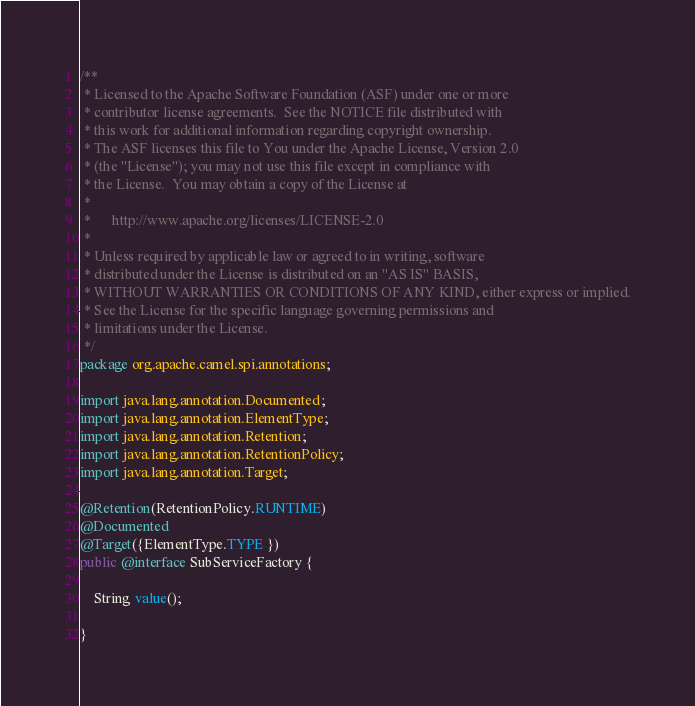Convert code to text. <code><loc_0><loc_0><loc_500><loc_500><_Java_>/**
 * Licensed to the Apache Software Foundation (ASF) under one or more
 * contributor license agreements.  See the NOTICE file distributed with
 * this work for additional information regarding copyright ownership.
 * The ASF licenses this file to You under the Apache License, Version 2.0
 * (the "License"); you may not use this file except in compliance with
 * the License.  You may obtain a copy of the License at
 *
 *      http://www.apache.org/licenses/LICENSE-2.0
 *
 * Unless required by applicable law or agreed to in writing, software
 * distributed under the License is distributed on an "AS IS" BASIS,
 * WITHOUT WARRANTIES OR CONDITIONS OF ANY KIND, either express or implied.
 * See the License for the specific language governing permissions and
 * limitations under the License.
 */
package org.apache.camel.spi.annotations;

import java.lang.annotation.Documented;
import java.lang.annotation.ElementType;
import java.lang.annotation.Retention;
import java.lang.annotation.RetentionPolicy;
import java.lang.annotation.Target;

@Retention(RetentionPolicy.RUNTIME)
@Documented
@Target({ElementType.TYPE })
public @interface SubServiceFactory {

    String value();

}
</code> 